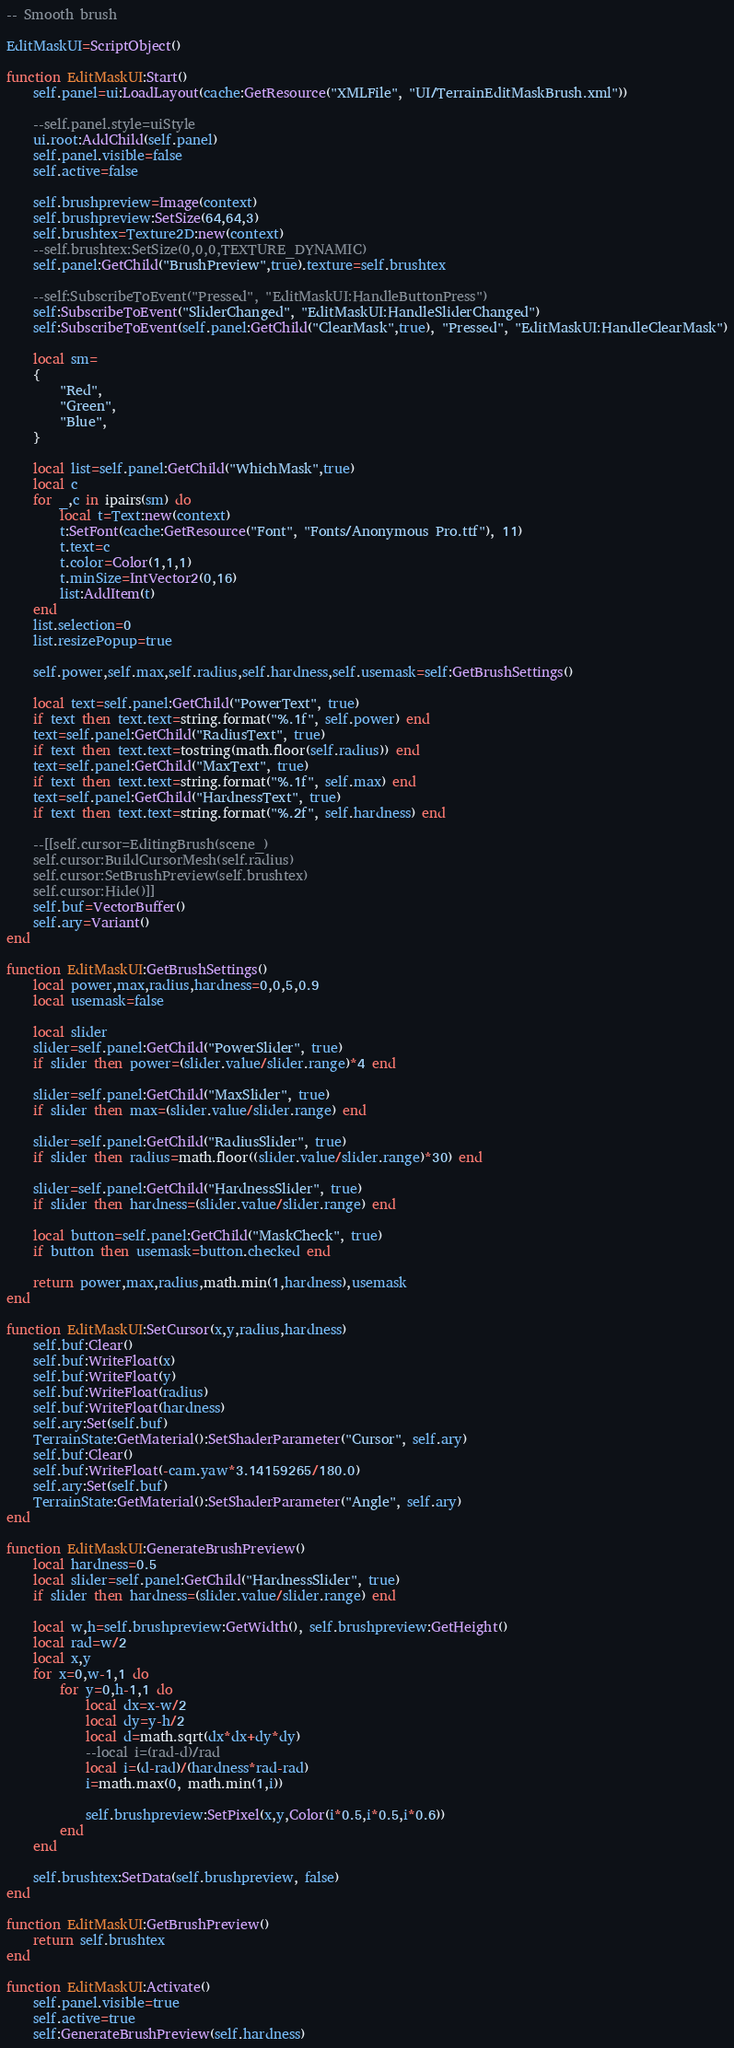<code> <loc_0><loc_0><loc_500><loc_500><_Lua_>-- Smooth brush

EditMaskUI=ScriptObject()

function EditMaskUI:Start()
	self.panel=ui:LoadLayout(cache:GetResource("XMLFile", "UI/TerrainEditMaskBrush.xml"))

	--self.panel.style=uiStyle
	ui.root:AddChild(self.panel)
	self.panel.visible=false
	self.active=false

	self.brushpreview=Image(context)
	self.brushpreview:SetSize(64,64,3)
	self.brushtex=Texture2D:new(context)
	--self.brushtex:SetSize(0,0,0,TEXTURE_DYNAMIC)
	self.panel:GetChild("BrushPreview",true).texture=self.brushtex

	--self:SubscribeToEvent("Pressed", "EditMaskUI:HandleButtonPress")
	self:SubscribeToEvent("SliderChanged", "EditMaskUI:HandleSliderChanged")
	self:SubscribeToEvent(self.panel:GetChild("ClearMask",true), "Pressed", "EditMaskUI:HandleClearMask")

	local sm=
	{
		"Red",
		"Green",
		"Blue",
	}

	local list=self.panel:GetChild("WhichMask",true)
	local c
	for _,c in ipairs(sm) do
		local t=Text:new(context)
		t:SetFont(cache:GetResource("Font", "Fonts/Anonymous Pro.ttf"), 11)
		t.text=c
		t.color=Color(1,1,1)
		t.minSize=IntVector2(0,16)
		list:AddItem(t)
	end
	list.selection=0
	list.resizePopup=true

	self.power,self.max,self.radius,self.hardness,self.usemask=self:GetBrushSettings()

	local text=self.panel:GetChild("PowerText", true)
	if text then text.text=string.format("%.1f", self.power) end
	text=self.panel:GetChild("RadiusText", true)
	if text then text.text=tostring(math.floor(self.radius)) end
	text=self.panel:GetChild("MaxText", true)
	if text then text.text=string.format("%.1f", self.max) end
	text=self.panel:GetChild("HardnessText", true)
	if text then text.text=string.format("%.2f", self.hardness) end

	--[[self.cursor=EditingBrush(scene_)
	self.cursor:BuildCursorMesh(self.radius)
	self.cursor:SetBrushPreview(self.brushtex)
	self.cursor:Hide()]]
	self.buf=VectorBuffer()
	self.ary=Variant()
end

function EditMaskUI:GetBrushSettings()
	local power,max,radius,hardness=0,0,5,0.9
	local usemask=false

	local slider
	slider=self.panel:GetChild("PowerSlider", true)
	if slider then power=(slider.value/slider.range)*4 end

	slider=self.panel:GetChild("MaxSlider", true)
	if slider then max=(slider.value/slider.range) end

	slider=self.panel:GetChild("RadiusSlider", true)
	if slider then radius=math.floor((slider.value/slider.range)*30) end

	slider=self.panel:GetChild("HardnessSlider", true)
	if slider then hardness=(slider.value/slider.range) end

	local button=self.panel:GetChild("MaskCheck", true)
	if button then usemask=button.checked end

	return power,max,radius,math.min(1,hardness),usemask
end

function EditMaskUI:SetCursor(x,y,radius,hardness)
	self.buf:Clear()
	self.buf:WriteFloat(x)
	self.buf:WriteFloat(y)
	self.buf:WriteFloat(radius)
	self.buf:WriteFloat(hardness)
	self.ary:Set(self.buf)
	TerrainState:GetMaterial():SetShaderParameter("Cursor", self.ary)
	self.buf:Clear()
	self.buf:WriteFloat(-cam.yaw*3.14159265/180.0)
	self.ary:Set(self.buf)
	TerrainState:GetMaterial():SetShaderParameter("Angle", self.ary)
end

function EditMaskUI:GenerateBrushPreview()
	local hardness=0.5
	local slider=self.panel:GetChild("HardnessSlider", true)
	if slider then hardness=(slider.value/slider.range) end

	local w,h=self.brushpreview:GetWidth(), self.brushpreview:GetHeight()
	local rad=w/2
	local x,y
	for x=0,w-1,1 do
		for y=0,h-1,1 do
			local dx=x-w/2
			local dy=y-h/2
			local d=math.sqrt(dx*dx+dy*dy)
			--local i=(rad-d)/rad
			local i=(d-rad)/(hardness*rad-rad)
			i=math.max(0, math.min(1,i))

			self.brushpreview:SetPixel(x,y,Color(i*0.5,i*0.5,i*0.6))
		end
	end

	self.brushtex:SetData(self.brushpreview, false)
end

function EditMaskUI:GetBrushPreview()
	return self.brushtex
end

function EditMaskUI:Activate()
	self.panel.visible=true
	self.active=true
	self:GenerateBrushPreview(self.hardness)</code> 